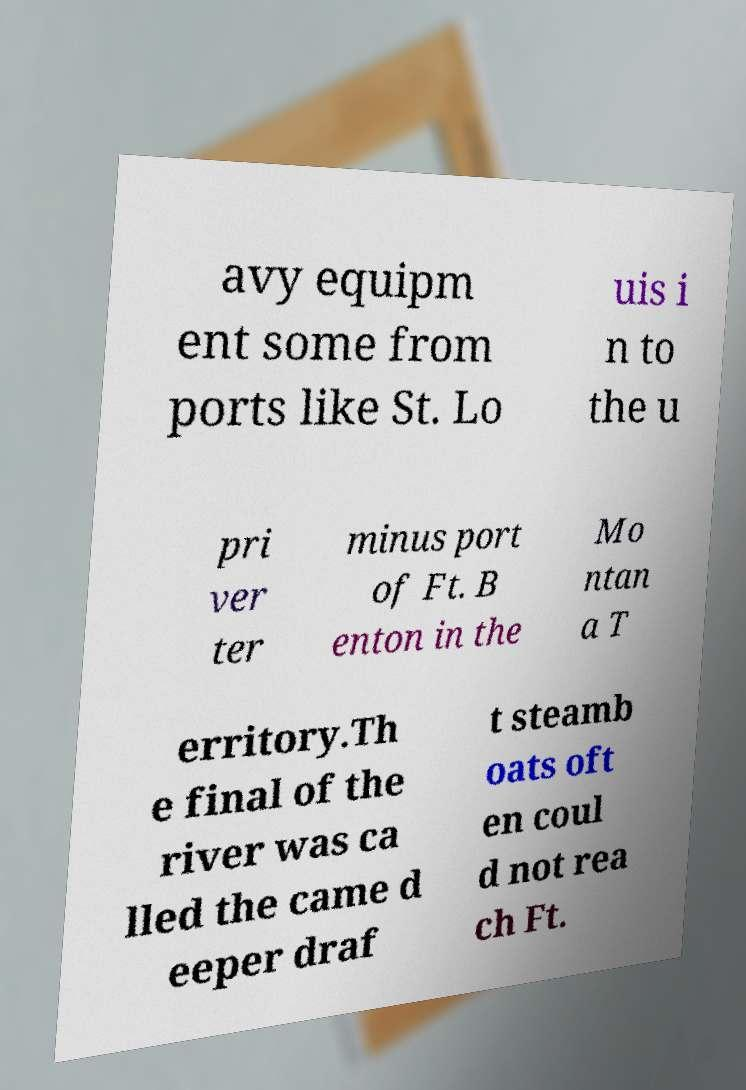I need the written content from this picture converted into text. Can you do that? avy equipm ent some from ports like St. Lo uis i n to the u pri ver ter minus port of Ft. B enton in the Mo ntan a T erritory.Th e final of the river was ca lled the came d eeper draf t steamb oats oft en coul d not rea ch Ft. 